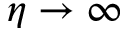Convert formula to latex. <formula><loc_0><loc_0><loc_500><loc_500>\eta \to \infty</formula> 